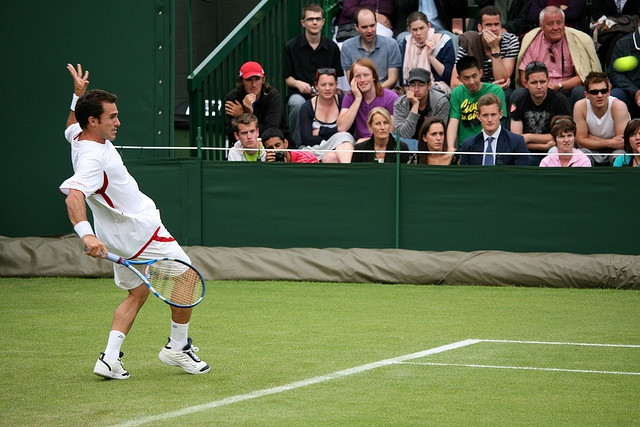Describe the objects in this image and their specific colors. I can see people in black, lightpink, brown, and lightgray tones, people in black, lightgray, darkgray, and brown tones, people in black, brown, tan, and maroon tones, people in black, gray, and tan tones, and people in black, brown, gray, and maroon tones in this image. 